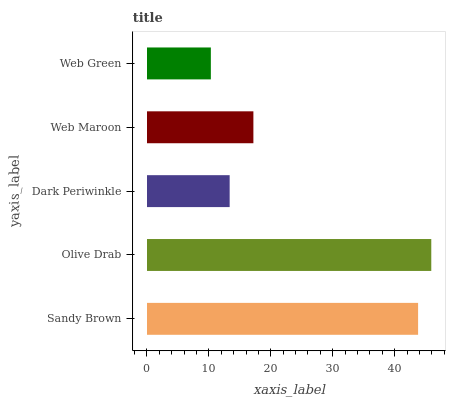Is Web Green the minimum?
Answer yes or no. Yes. Is Olive Drab the maximum?
Answer yes or no. Yes. Is Dark Periwinkle the minimum?
Answer yes or no. No. Is Dark Periwinkle the maximum?
Answer yes or no. No. Is Olive Drab greater than Dark Periwinkle?
Answer yes or no. Yes. Is Dark Periwinkle less than Olive Drab?
Answer yes or no. Yes. Is Dark Periwinkle greater than Olive Drab?
Answer yes or no. No. Is Olive Drab less than Dark Periwinkle?
Answer yes or no. No. Is Web Maroon the high median?
Answer yes or no. Yes. Is Web Maroon the low median?
Answer yes or no. Yes. Is Dark Periwinkle the high median?
Answer yes or no. No. Is Web Green the low median?
Answer yes or no. No. 